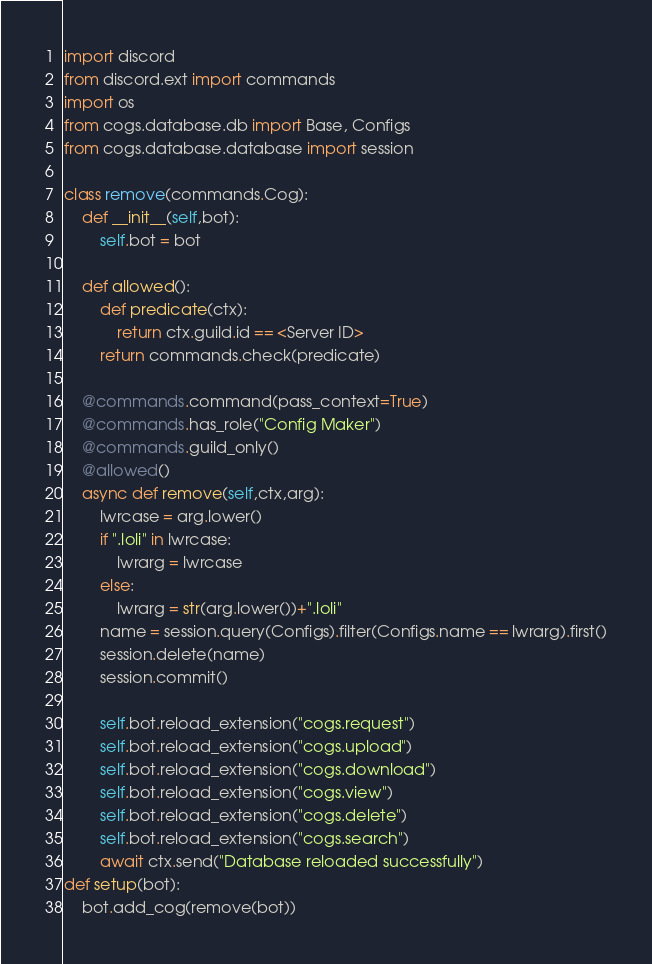<code> <loc_0><loc_0><loc_500><loc_500><_Python_>import discord
from discord.ext import commands
import os
from cogs.database.db import Base, Configs
from cogs.database.database import session

class remove(commands.Cog):
	def __init__(self,bot):
		self.bot = bot
		
	def allowed():
		def predicate(ctx):
			return ctx.guild.id == <Server ID>
		return commands.check(predicate)
		
	@commands.command(pass_context=True)
	@commands.has_role("Config Maker")
	@commands.guild_only()
	@allowed()
	async def remove(self,ctx,arg):
		lwrcase = arg.lower()
		if ".loli" in lwrcase:
			lwrarg = lwrcase
		else:
			lwrarg = str(arg.lower())+".loli"
		name = session.query(Configs).filter(Configs.name == lwrarg).first()
		session.delete(name)
		session.commit()
		
		self.bot.reload_extension("cogs.request")
		self.bot.reload_extension("cogs.upload")
		self.bot.reload_extension("cogs.download")
		self.bot.reload_extension("cogs.view")
		self.bot.reload_extension("cogs.delete")
		self.bot.reload_extension("cogs.search")
		await ctx.send("Database reloaded successfully")
def setup(bot):
	bot.add_cog(remove(bot))</code> 